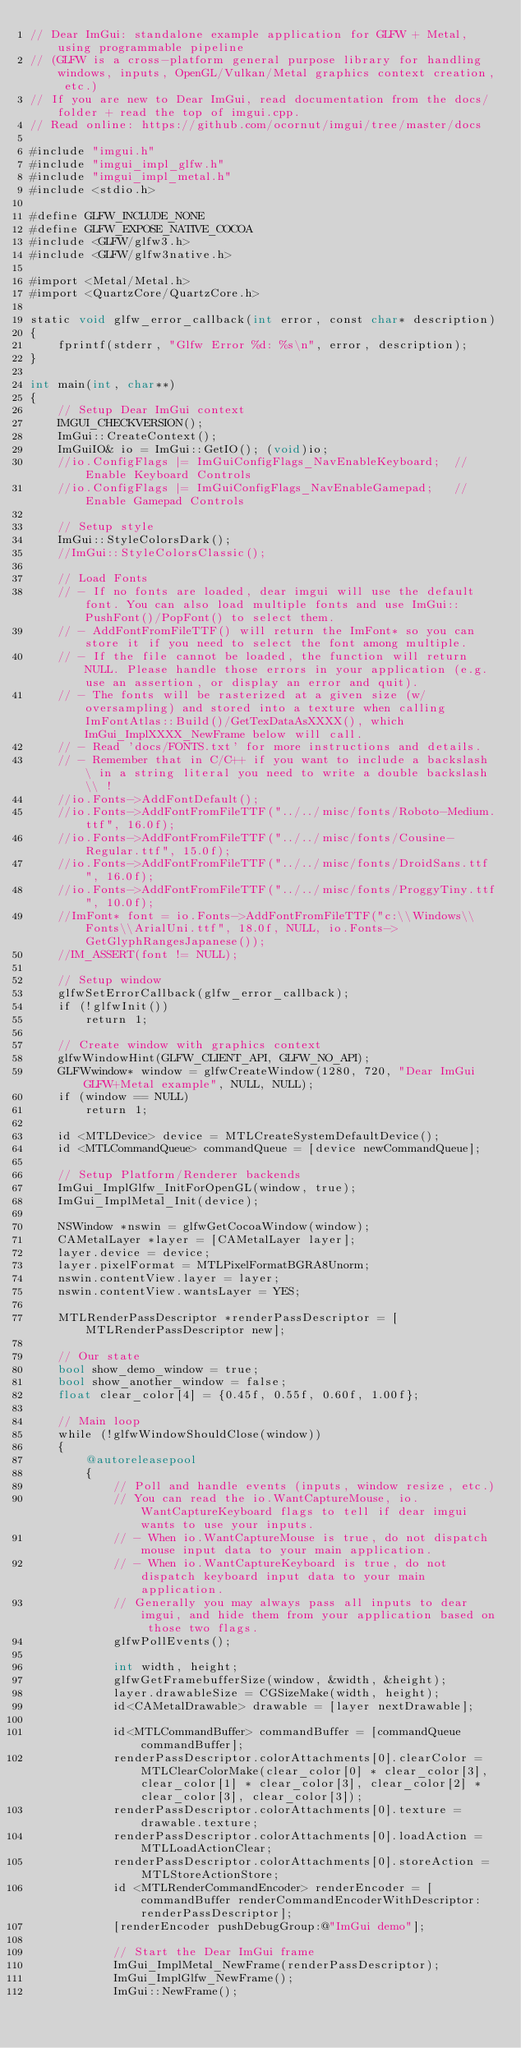Convert code to text. <code><loc_0><loc_0><loc_500><loc_500><_ObjectiveC_>// Dear ImGui: standalone example application for GLFW + Metal, using programmable pipeline
// (GLFW is a cross-platform general purpose library for handling windows, inputs, OpenGL/Vulkan/Metal graphics context creation, etc.)
// If you are new to Dear ImGui, read documentation from the docs/ folder + read the top of imgui.cpp.
// Read online: https://github.com/ocornut/imgui/tree/master/docs

#include "imgui.h"
#include "imgui_impl_glfw.h"
#include "imgui_impl_metal.h"
#include <stdio.h>

#define GLFW_INCLUDE_NONE
#define GLFW_EXPOSE_NATIVE_COCOA
#include <GLFW/glfw3.h>
#include <GLFW/glfw3native.h>

#import <Metal/Metal.h>
#import <QuartzCore/QuartzCore.h>

static void glfw_error_callback(int error, const char* description)
{
    fprintf(stderr, "Glfw Error %d: %s\n", error, description);
}

int main(int, char**)
{
    // Setup Dear ImGui context
    IMGUI_CHECKVERSION();
    ImGui::CreateContext();
    ImGuiIO& io = ImGui::GetIO(); (void)io;
    //io.ConfigFlags |= ImGuiConfigFlags_NavEnableKeyboard;  // Enable Keyboard Controls
    //io.ConfigFlags |= ImGuiConfigFlags_NavEnableGamepad;   // Enable Gamepad Controls

    // Setup style
    ImGui::StyleColorsDark();
    //ImGui::StyleColorsClassic();

    // Load Fonts
    // - If no fonts are loaded, dear imgui will use the default font. You can also load multiple fonts and use ImGui::PushFont()/PopFont() to select them.
    // - AddFontFromFileTTF() will return the ImFont* so you can store it if you need to select the font among multiple.
    // - If the file cannot be loaded, the function will return NULL. Please handle those errors in your application (e.g. use an assertion, or display an error and quit).
    // - The fonts will be rasterized at a given size (w/ oversampling) and stored into a texture when calling ImFontAtlas::Build()/GetTexDataAsXXXX(), which ImGui_ImplXXXX_NewFrame below will call.
    // - Read 'docs/FONTS.txt' for more instructions and details.
    // - Remember that in C/C++ if you want to include a backslash \ in a string literal you need to write a double backslash \\ !
    //io.Fonts->AddFontDefault();
    //io.Fonts->AddFontFromFileTTF("../../misc/fonts/Roboto-Medium.ttf", 16.0f);
    //io.Fonts->AddFontFromFileTTF("../../misc/fonts/Cousine-Regular.ttf", 15.0f);
    //io.Fonts->AddFontFromFileTTF("../../misc/fonts/DroidSans.ttf", 16.0f);
    //io.Fonts->AddFontFromFileTTF("../../misc/fonts/ProggyTiny.ttf", 10.0f);
    //ImFont* font = io.Fonts->AddFontFromFileTTF("c:\\Windows\\Fonts\\ArialUni.ttf", 18.0f, NULL, io.Fonts->GetGlyphRangesJapanese());
    //IM_ASSERT(font != NULL);

    // Setup window
    glfwSetErrorCallback(glfw_error_callback);
    if (!glfwInit())
        return 1;

    // Create window with graphics context
    glfwWindowHint(GLFW_CLIENT_API, GLFW_NO_API);
    GLFWwindow* window = glfwCreateWindow(1280, 720, "Dear ImGui GLFW+Metal example", NULL, NULL);
    if (window == NULL)
        return 1;

    id <MTLDevice> device = MTLCreateSystemDefaultDevice();
    id <MTLCommandQueue> commandQueue = [device newCommandQueue];

    // Setup Platform/Renderer backends
    ImGui_ImplGlfw_InitForOpenGL(window, true);
    ImGui_ImplMetal_Init(device);

    NSWindow *nswin = glfwGetCocoaWindow(window);
    CAMetalLayer *layer = [CAMetalLayer layer];
    layer.device = device;
    layer.pixelFormat = MTLPixelFormatBGRA8Unorm;
    nswin.contentView.layer = layer;
    nswin.contentView.wantsLayer = YES;

    MTLRenderPassDescriptor *renderPassDescriptor = [MTLRenderPassDescriptor new];

    // Our state
    bool show_demo_window = true;
    bool show_another_window = false;
    float clear_color[4] = {0.45f, 0.55f, 0.60f, 1.00f};

    // Main loop
    while (!glfwWindowShouldClose(window))
    {
        @autoreleasepool
        {
            // Poll and handle events (inputs, window resize, etc.)
            // You can read the io.WantCaptureMouse, io.WantCaptureKeyboard flags to tell if dear imgui wants to use your inputs.
            // - When io.WantCaptureMouse is true, do not dispatch mouse input data to your main application.
            // - When io.WantCaptureKeyboard is true, do not dispatch keyboard input data to your main application.
            // Generally you may always pass all inputs to dear imgui, and hide them from your application based on those two flags.
            glfwPollEvents();

            int width, height;
            glfwGetFramebufferSize(window, &width, &height);
            layer.drawableSize = CGSizeMake(width, height);
            id<CAMetalDrawable> drawable = [layer nextDrawable];

            id<MTLCommandBuffer> commandBuffer = [commandQueue commandBuffer];
            renderPassDescriptor.colorAttachments[0].clearColor = MTLClearColorMake(clear_color[0] * clear_color[3], clear_color[1] * clear_color[3], clear_color[2] * clear_color[3], clear_color[3]);
            renderPassDescriptor.colorAttachments[0].texture = drawable.texture;
            renderPassDescriptor.colorAttachments[0].loadAction = MTLLoadActionClear;
            renderPassDescriptor.colorAttachments[0].storeAction = MTLStoreActionStore;
            id <MTLRenderCommandEncoder> renderEncoder = [commandBuffer renderCommandEncoderWithDescriptor:renderPassDescriptor];
            [renderEncoder pushDebugGroup:@"ImGui demo"];

            // Start the Dear ImGui frame
            ImGui_ImplMetal_NewFrame(renderPassDescriptor);
            ImGui_ImplGlfw_NewFrame();
            ImGui::NewFrame();
</code> 